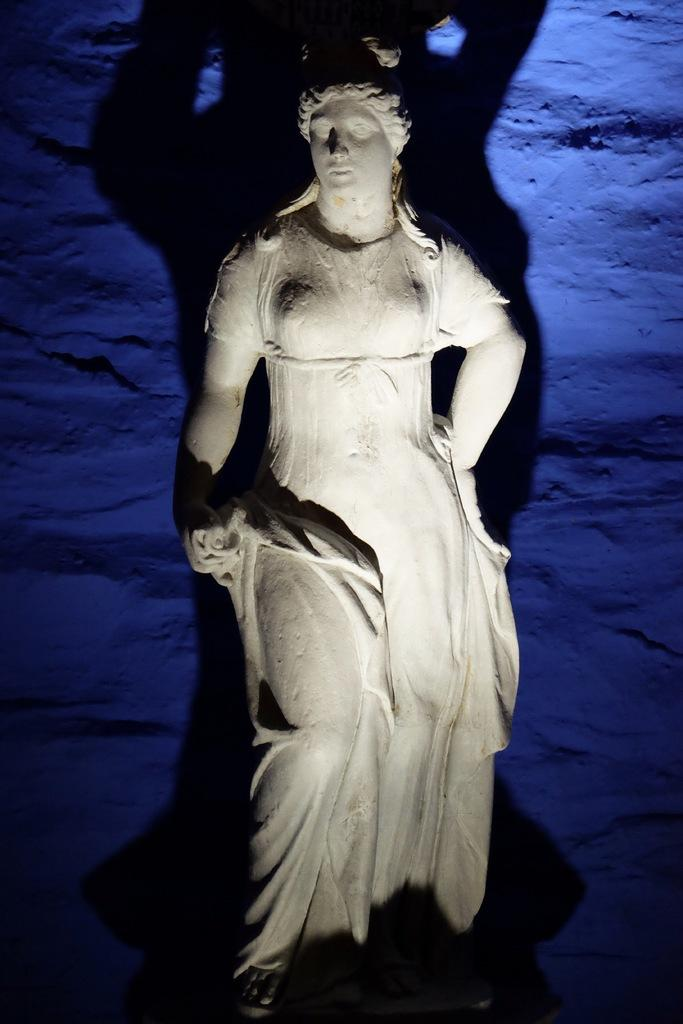What is the main subject in the middle of the image? There is a statue in the middle of the image. What color can be seen in the background of the image? There is a blue color in the background of the image. Can you describe any additional features of the statue in the image? There is a shadow of the statue visible in the image. What is the annual income of the statue's representative in the image? There is no information about a representative or income in the image, as it only features a statue with a shadow. 